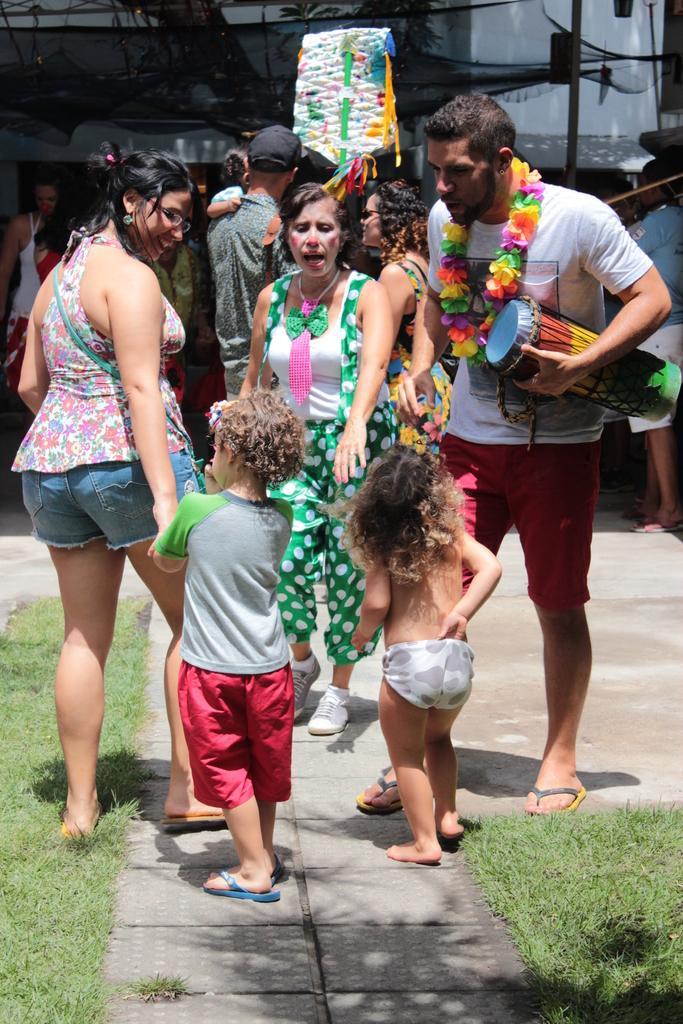In one or two sentences, can you explain what this image depicts? In the foreground of the picture there are kids, women, man holding a tabla, grass and payment. In the background there are people, trees, net and a building. It is sunny. 